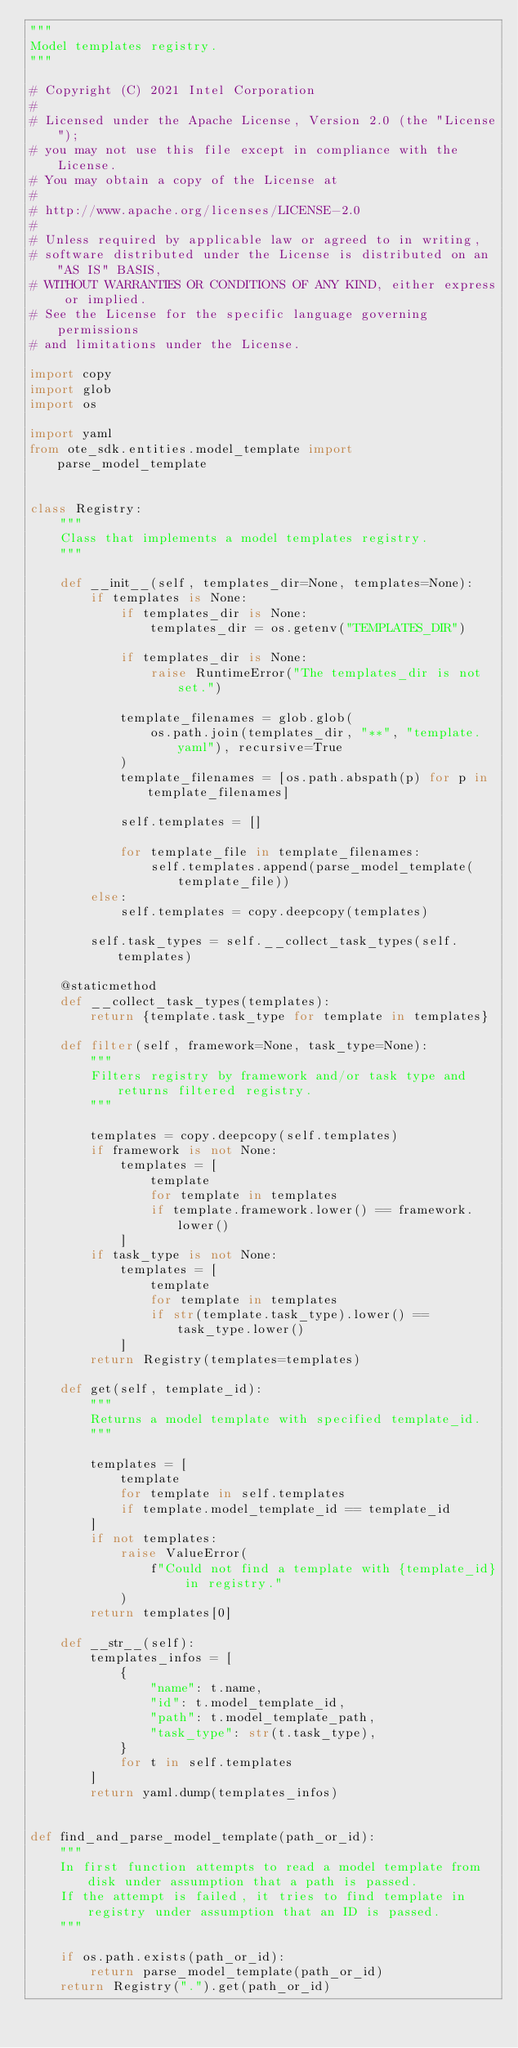<code> <loc_0><loc_0><loc_500><loc_500><_Python_>"""
Model templates registry.
"""

# Copyright (C) 2021 Intel Corporation
#
# Licensed under the Apache License, Version 2.0 (the "License");
# you may not use this file except in compliance with the License.
# You may obtain a copy of the License at
#
# http://www.apache.org/licenses/LICENSE-2.0
#
# Unless required by applicable law or agreed to in writing,
# software distributed under the License is distributed on an "AS IS" BASIS,
# WITHOUT WARRANTIES OR CONDITIONS OF ANY KIND, either express or implied.
# See the License for the specific language governing permissions
# and limitations under the License.

import copy
import glob
import os

import yaml
from ote_sdk.entities.model_template import parse_model_template


class Registry:
    """
    Class that implements a model templates registry.
    """

    def __init__(self, templates_dir=None, templates=None):
        if templates is None:
            if templates_dir is None:
                templates_dir = os.getenv("TEMPLATES_DIR")

            if templates_dir is None:
                raise RuntimeError("The templates_dir is not set.")

            template_filenames = glob.glob(
                os.path.join(templates_dir, "**", "template.yaml"), recursive=True
            )
            template_filenames = [os.path.abspath(p) for p in template_filenames]

            self.templates = []

            for template_file in template_filenames:
                self.templates.append(parse_model_template(template_file))
        else:
            self.templates = copy.deepcopy(templates)

        self.task_types = self.__collect_task_types(self.templates)

    @staticmethod
    def __collect_task_types(templates):
        return {template.task_type for template in templates}

    def filter(self, framework=None, task_type=None):
        """
        Filters registry by framework and/or task type and returns filtered registry.
        """

        templates = copy.deepcopy(self.templates)
        if framework is not None:
            templates = [
                template
                for template in templates
                if template.framework.lower() == framework.lower()
            ]
        if task_type is not None:
            templates = [
                template
                for template in templates
                if str(template.task_type).lower() == task_type.lower()
            ]
        return Registry(templates=templates)

    def get(self, template_id):
        """
        Returns a model template with specified template_id.
        """

        templates = [
            template
            for template in self.templates
            if template.model_template_id == template_id
        ]
        if not templates:
            raise ValueError(
                f"Could not find a template with {template_id} in registry."
            )
        return templates[0]

    def __str__(self):
        templates_infos = [
            {
                "name": t.name,
                "id": t.model_template_id,
                "path": t.model_template_path,
                "task_type": str(t.task_type),
            }
            for t in self.templates
        ]
        return yaml.dump(templates_infos)


def find_and_parse_model_template(path_or_id):
    """
    In first function attempts to read a model template from disk under assumption that a path is passed.
    If the attempt is failed, it tries to find template in registry under assumption that an ID is passed.
    """

    if os.path.exists(path_or_id):
        return parse_model_template(path_or_id)
    return Registry(".").get(path_or_id)
</code> 